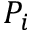<formula> <loc_0><loc_0><loc_500><loc_500>P _ { i }</formula> 